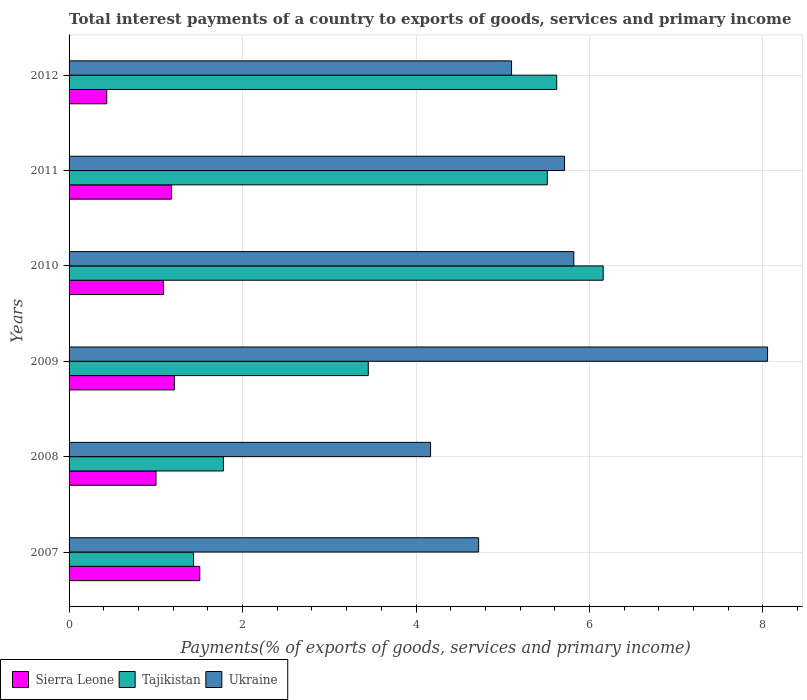How many different coloured bars are there?
Offer a very short reply. 3. How many bars are there on the 2nd tick from the bottom?
Your answer should be compact. 3. What is the label of the 6th group of bars from the top?
Keep it short and to the point. 2007. In how many cases, is the number of bars for a given year not equal to the number of legend labels?
Ensure brevity in your answer.  0. What is the total interest payments in Ukraine in 2011?
Your response must be concise. 5.71. Across all years, what is the maximum total interest payments in Tajikistan?
Give a very brief answer. 6.16. Across all years, what is the minimum total interest payments in Ukraine?
Offer a terse response. 4.17. In which year was the total interest payments in Ukraine maximum?
Ensure brevity in your answer.  2009. In which year was the total interest payments in Sierra Leone minimum?
Provide a short and direct response. 2012. What is the total total interest payments in Ukraine in the graph?
Keep it short and to the point. 33.58. What is the difference between the total interest payments in Sierra Leone in 2010 and that in 2012?
Provide a short and direct response. 0.65. What is the difference between the total interest payments in Tajikistan in 2009 and the total interest payments in Ukraine in 2011?
Your answer should be very brief. -2.26. What is the average total interest payments in Tajikistan per year?
Your answer should be compact. 3.99. In the year 2008, what is the difference between the total interest payments in Ukraine and total interest payments in Tajikistan?
Offer a terse response. 2.39. In how many years, is the total interest payments in Tajikistan greater than 6.8 %?
Your response must be concise. 0. What is the ratio of the total interest payments in Ukraine in 2010 to that in 2011?
Offer a very short reply. 1.02. Is the total interest payments in Sierra Leone in 2009 less than that in 2010?
Provide a short and direct response. No. Is the difference between the total interest payments in Ukraine in 2009 and 2010 greater than the difference between the total interest payments in Tajikistan in 2009 and 2010?
Your answer should be very brief. Yes. What is the difference between the highest and the second highest total interest payments in Sierra Leone?
Your answer should be compact. 0.29. What is the difference between the highest and the lowest total interest payments in Ukraine?
Your answer should be compact. 3.89. Is the sum of the total interest payments in Tajikistan in 2008 and 2012 greater than the maximum total interest payments in Ukraine across all years?
Your answer should be very brief. No. What does the 1st bar from the top in 2012 represents?
Provide a short and direct response. Ukraine. What does the 1st bar from the bottom in 2010 represents?
Offer a terse response. Sierra Leone. Are all the bars in the graph horizontal?
Your answer should be very brief. Yes. How many years are there in the graph?
Your answer should be very brief. 6. What is the difference between two consecutive major ticks on the X-axis?
Provide a short and direct response. 2. Does the graph contain any zero values?
Your answer should be compact. No. Does the graph contain grids?
Keep it short and to the point. Yes. Where does the legend appear in the graph?
Your answer should be compact. Bottom left. How many legend labels are there?
Give a very brief answer. 3. What is the title of the graph?
Provide a succinct answer. Total interest payments of a country to exports of goods, services and primary income. Does "Ireland" appear as one of the legend labels in the graph?
Your response must be concise. No. What is the label or title of the X-axis?
Give a very brief answer. Payments(% of exports of goods, services and primary income). What is the label or title of the Y-axis?
Provide a succinct answer. Years. What is the Payments(% of exports of goods, services and primary income) in Sierra Leone in 2007?
Give a very brief answer. 1.51. What is the Payments(% of exports of goods, services and primary income) of Tajikistan in 2007?
Make the answer very short. 1.43. What is the Payments(% of exports of goods, services and primary income) in Ukraine in 2007?
Give a very brief answer. 4.72. What is the Payments(% of exports of goods, services and primary income) in Sierra Leone in 2008?
Ensure brevity in your answer.  1. What is the Payments(% of exports of goods, services and primary income) in Tajikistan in 2008?
Keep it short and to the point. 1.78. What is the Payments(% of exports of goods, services and primary income) in Ukraine in 2008?
Provide a short and direct response. 4.17. What is the Payments(% of exports of goods, services and primary income) in Sierra Leone in 2009?
Provide a short and direct response. 1.21. What is the Payments(% of exports of goods, services and primary income) in Tajikistan in 2009?
Provide a short and direct response. 3.45. What is the Payments(% of exports of goods, services and primary income) in Ukraine in 2009?
Provide a succinct answer. 8.05. What is the Payments(% of exports of goods, services and primary income) in Sierra Leone in 2010?
Ensure brevity in your answer.  1.09. What is the Payments(% of exports of goods, services and primary income) in Tajikistan in 2010?
Your response must be concise. 6.16. What is the Payments(% of exports of goods, services and primary income) of Ukraine in 2010?
Offer a very short reply. 5.82. What is the Payments(% of exports of goods, services and primary income) in Sierra Leone in 2011?
Offer a very short reply. 1.18. What is the Payments(% of exports of goods, services and primary income) of Tajikistan in 2011?
Provide a short and direct response. 5.51. What is the Payments(% of exports of goods, services and primary income) in Ukraine in 2011?
Provide a succinct answer. 5.71. What is the Payments(% of exports of goods, services and primary income) of Sierra Leone in 2012?
Keep it short and to the point. 0.43. What is the Payments(% of exports of goods, services and primary income) of Tajikistan in 2012?
Provide a succinct answer. 5.62. What is the Payments(% of exports of goods, services and primary income) in Ukraine in 2012?
Make the answer very short. 5.1. Across all years, what is the maximum Payments(% of exports of goods, services and primary income) in Sierra Leone?
Keep it short and to the point. 1.51. Across all years, what is the maximum Payments(% of exports of goods, services and primary income) in Tajikistan?
Offer a terse response. 6.16. Across all years, what is the maximum Payments(% of exports of goods, services and primary income) of Ukraine?
Your answer should be compact. 8.05. Across all years, what is the minimum Payments(% of exports of goods, services and primary income) in Sierra Leone?
Your response must be concise. 0.43. Across all years, what is the minimum Payments(% of exports of goods, services and primary income) in Tajikistan?
Your answer should be very brief. 1.43. Across all years, what is the minimum Payments(% of exports of goods, services and primary income) of Ukraine?
Provide a short and direct response. 4.17. What is the total Payments(% of exports of goods, services and primary income) in Sierra Leone in the graph?
Make the answer very short. 6.43. What is the total Payments(% of exports of goods, services and primary income) in Tajikistan in the graph?
Provide a succinct answer. 23.96. What is the total Payments(% of exports of goods, services and primary income) of Ukraine in the graph?
Your answer should be compact. 33.58. What is the difference between the Payments(% of exports of goods, services and primary income) of Sierra Leone in 2007 and that in 2008?
Make the answer very short. 0.5. What is the difference between the Payments(% of exports of goods, services and primary income) of Tajikistan in 2007 and that in 2008?
Provide a succinct answer. -0.34. What is the difference between the Payments(% of exports of goods, services and primary income) in Ukraine in 2007 and that in 2008?
Make the answer very short. 0.55. What is the difference between the Payments(% of exports of goods, services and primary income) of Sierra Leone in 2007 and that in 2009?
Offer a very short reply. 0.29. What is the difference between the Payments(% of exports of goods, services and primary income) of Tajikistan in 2007 and that in 2009?
Provide a succinct answer. -2.01. What is the difference between the Payments(% of exports of goods, services and primary income) of Ukraine in 2007 and that in 2009?
Give a very brief answer. -3.33. What is the difference between the Payments(% of exports of goods, services and primary income) in Sierra Leone in 2007 and that in 2010?
Offer a terse response. 0.42. What is the difference between the Payments(% of exports of goods, services and primary income) in Tajikistan in 2007 and that in 2010?
Give a very brief answer. -4.72. What is the difference between the Payments(% of exports of goods, services and primary income) in Ukraine in 2007 and that in 2010?
Give a very brief answer. -1.1. What is the difference between the Payments(% of exports of goods, services and primary income) in Sierra Leone in 2007 and that in 2011?
Your answer should be very brief. 0.33. What is the difference between the Payments(% of exports of goods, services and primary income) in Tajikistan in 2007 and that in 2011?
Provide a succinct answer. -4.08. What is the difference between the Payments(% of exports of goods, services and primary income) in Ukraine in 2007 and that in 2011?
Provide a succinct answer. -0.99. What is the difference between the Payments(% of exports of goods, services and primary income) of Sierra Leone in 2007 and that in 2012?
Keep it short and to the point. 1.07. What is the difference between the Payments(% of exports of goods, services and primary income) in Tajikistan in 2007 and that in 2012?
Offer a terse response. -4.19. What is the difference between the Payments(% of exports of goods, services and primary income) of Ukraine in 2007 and that in 2012?
Your answer should be very brief. -0.38. What is the difference between the Payments(% of exports of goods, services and primary income) in Sierra Leone in 2008 and that in 2009?
Your response must be concise. -0.21. What is the difference between the Payments(% of exports of goods, services and primary income) in Tajikistan in 2008 and that in 2009?
Ensure brevity in your answer.  -1.67. What is the difference between the Payments(% of exports of goods, services and primary income) of Ukraine in 2008 and that in 2009?
Provide a succinct answer. -3.89. What is the difference between the Payments(% of exports of goods, services and primary income) in Sierra Leone in 2008 and that in 2010?
Your response must be concise. -0.09. What is the difference between the Payments(% of exports of goods, services and primary income) of Tajikistan in 2008 and that in 2010?
Ensure brevity in your answer.  -4.38. What is the difference between the Payments(% of exports of goods, services and primary income) in Ukraine in 2008 and that in 2010?
Ensure brevity in your answer.  -1.65. What is the difference between the Payments(% of exports of goods, services and primary income) in Sierra Leone in 2008 and that in 2011?
Offer a very short reply. -0.18. What is the difference between the Payments(% of exports of goods, services and primary income) in Tajikistan in 2008 and that in 2011?
Offer a terse response. -3.73. What is the difference between the Payments(% of exports of goods, services and primary income) of Ukraine in 2008 and that in 2011?
Keep it short and to the point. -1.54. What is the difference between the Payments(% of exports of goods, services and primary income) in Sierra Leone in 2008 and that in 2012?
Offer a very short reply. 0.57. What is the difference between the Payments(% of exports of goods, services and primary income) of Tajikistan in 2008 and that in 2012?
Ensure brevity in your answer.  -3.84. What is the difference between the Payments(% of exports of goods, services and primary income) of Ukraine in 2008 and that in 2012?
Make the answer very short. -0.93. What is the difference between the Payments(% of exports of goods, services and primary income) of Sierra Leone in 2009 and that in 2010?
Provide a succinct answer. 0.13. What is the difference between the Payments(% of exports of goods, services and primary income) in Tajikistan in 2009 and that in 2010?
Provide a short and direct response. -2.71. What is the difference between the Payments(% of exports of goods, services and primary income) of Ukraine in 2009 and that in 2010?
Ensure brevity in your answer.  2.23. What is the difference between the Payments(% of exports of goods, services and primary income) in Sierra Leone in 2009 and that in 2011?
Keep it short and to the point. 0.03. What is the difference between the Payments(% of exports of goods, services and primary income) of Tajikistan in 2009 and that in 2011?
Offer a very short reply. -2.06. What is the difference between the Payments(% of exports of goods, services and primary income) of Ukraine in 2009 and that in 2011?
Offer a very short reply. 2.34. What is the difference between the Payments(% of exports of goods, services and primary income) of Sierra Leone in 2009 and that in 2012?
Your answer should be compact. 0.78. What is the difference between the Payments(% of exports of goods, services and primary income) of Tajikistan in 2009 and that in 2012?
Ensure brevity in your answer.  -2.17. What is the difference between the Payments(% of exports of goods, services and primary income) of Ukraine in 2009 and that in 2012?
Make the answer very short. 2.95. What is the difference between the Payments(% of exports of goods, services and primary income) in Sierra Leone in 2010 and that in 2011?
Your answer should be very brief. -0.09. What is the difference between the Payments(% of exports of goods, services and primary income) in Tajikistan in 2010 and that in 2011?
Keep it short and to the point. 0.64. What is the difference between the Payments(% of exports of goods, services and primary income) in Ukraine in 2010 and that in 2011?
Make the answer very short. 0.11. What is the difference between the Payments(% of exports of goods, services and primary income) of Sierra Leone in 2010 and that in 2012?
Offer a very short reply. 0.65. What is the difference between the Payments(% of exports of goods, services and primary income) in Tajikistan in 2010 and that in 2012?
Ensure brevity in your answer.  0.54. What is the difference between the Payments(% of exports of goods, services and primary income) in Ukraine in 2010 and that in 2012?
Your response must be concise. 0.72. What is the difference between the Payments(% of exports of goods, services and primary income) of Sierra Leone in 2011 and that in 2012?
Your answer should be compact. 0.75. What is the difference between the Payments(% of exports of goods, services and primary income) in Tajikistan in 2011 and that in 2012?
Offer a very short reply. -0.11. What is the difference between the Payments(% of exports of goods, services and primary income) in Ukraine in 2011 and that in 2012?
Ensure brevity in your answer.  0.61. What is the difference between the Payments(% of exports of goods, services and primary income) of Sierra Leone in 2007 and the Payments(% of exports of goods, services and primary income) of Tajikistan in 2008?
Give a very brief answer. -0.27. What is the difference between the Payments(% of exports of goods, services and primary income) in Sierra Leone in 2007 and the Payments(% of exports of goods, services and primary income) in Ukraine in 2008?
Your answer should be very brief. -2.66. What is the difference between the Payments(% of exports of goods, services and primary income) in Tajikistan in 2007 and the Payments(% of exports of goods, services and primary income) in Ukraine in 2008?
Your response must be concise. -2.73. What is the difference between the Payments(% of exports of goods, services and primary income) in Sierra Leone in 2007 and the Payments(% of exports of goods, services and primary income) in Tajikistan in 2009?
Ensure brevity in your answer.  -1.94. What is the difference between the Payments(% of exports of goods, services and primary income) of Sierra Leone in 2007 and the Payments(% of exports of goods, services and primary income) of Ukraine in 2009?
Ensure brevity in your answer.  -6.55. What is the difference between the Payments(% of exports of goods, services and primary income) in Tajikistan in 2007 and the Payments(% of exports of goods, services and primary income) in Ukraine in 2009?
Provide a succinct answer. -6.62. What is the difference between the Payments(% of exports of goods, services and primary income) in Sierra Leone in 2007 and the Payments(% of exports of goods, services and primary income) in Tajikistan in 2010?
Provide a short and direct response. -4.65. What is the difference between the Payments(% of exports of goods, services and primary income) of Sierra Leone in 2007 and the Payments(% of exports of goods, services and primary income) of Ukraine in 2010?
Provide a succinct answer. -4.31. What is the difference between the Payments(% of exports of goods, services and primary income) of Tajikistan in 2007 and the Payments(% of exports of goods, services and primary income) of Ukraine in 2010?
Make the answer very short. -4.38. What is the difference between the Payments(% of exports of goods, services and primary income) of Sierra Leone in 2007 and the Payments(% of exports of goods, services and primary income) of Tajikistan in 2011?
Keep it short and to the point. -4.01. What is the difference between the Payments(% of exports of goods, services and primary income) in Sierra Leone in 2007 and the Payments(% of exports of goods, services and primary income) in Ukraine in 2011?
Offer a terse response. -4.21. What is the difference between the Payments(% of exports of goods, services and primary income) of Tajikistan in 2007 and the Payments(% of exports of goods, services and primary income) of Ukraine in 2011?
Your answer should be compact. -4.28. What is the difference between the Payments(% of exports of goods, services and primary income) in Sierra Leone in 2007 and the Payments(% of exports of goods, services and primary income) in Tajikistan in 2012?
Make the answer very short. -4.12. What is the difference between the Payments(% of exports of goods, services and primary income) of Sierra Leone in 2007 and the Payments(% of exports of goods, services and primary income) of Ukraine in 2012?
Offer a terse response. -3.59. What is the difference between the Payments(% of exports of goods, services and primary income) of Tajikistan in 2007 and the Payments(% of exports of goods, services and primary income) of Ukraine in 2012?
Offer a very short reply. -3.67. What is the difference between the Payments(% of exports of goods, services and primary income) of Sierra Leone in 2008 and the Payments(% of exports of goods, services and primary income) of Tajikistan in 2009?
Offer a terse response. -2.45. What is the difference between the Payments(% of exports of goods, services and primary income) of Sierra Leone in 2008 and the Payments(% of exports of goods, services and primary income) of Ukraine in 2009?
Give a very brief answer. -7.05. What is the difference between the Payments(% of exports of goods, services and primary income) of Tajikistan in 2008 and the Payments(% of exports of goods, services and primary income) of Ukraine in 2009?
Ensure brevity in your answer.  -6.27. What is the difference between the Payments(% of exports of goods, services and primary income) of Sierra Leone in 2008 and the Payments(% of exports of goods, services and primary income) of Tajikistan in 2010?
Keep it short and to the point. -5.16. What is the difference between the Payments(% of exports of goods, services and primary income) in Sierra Leone in 2008 and the Payments(% of exports of goods, services and primary income) in Ukraine in 2010?
Provide a short and direct response. -4.82. What is the difference between the Payments(% of exports of goods, services and primary income) in Tajikistan in 2008 and the Payments(% of exports of goods, services and primary income) in Ukraine in 2010?
Offer a terse response. -4.04. What is the difference between the Payments(% of exports of goods, services and primary income) of Sierra Leone in 2008 and the Payments(% of exports of goods, services and primary income) of Tajikistan in 2011?
Make the answer very short. -4.51. What is the difference between the Payments(% of exports of goods, services and primary income) in Sierra Leone in 2008 and the Payments(% of exports of goods, services and primary income) in Ukraine in 2011?
Keep it short and to the point. -4.71. What is the difference between the Payments(% of exports of goods, services and primary income) in Tajikistan in 2008 and the Payments(% of exports of goods, services and primary income) in Ukraine in 2011?
Keep it short and to the point. -3.93. What is the difference between the Payments(% of exports of goods, services and primary income) of Sierra Leone in 2008 and the Payments(% of exports of goods, services and primary income) of Tajikistan in 2012?
Keep it short and to the point. -4.62. What is the difference between the Payments(% of exports of goods, services and primary income) of Sierra Leone in 2008 and the Payments(% of exports of goods, services and primary income) of Ukraine in 2012?
Your answer should be very brief. -4.1. What is the difference between the Payments(% of exports of goods, services and primary income) of Tajikistan in 2008 and the Payments(% of exports of goods, services and primary income) of Ukraine in 2012?
Your answer should be very brief. -3.32. What is the difference between the Payments(% of exports of goods, services and primary income) of Sierra Leone in 2009 and the Payments(% of exports of goods, services and primary income) of Tajikistan in 2010?
Give a very brief answer. -4.94. What is the difference between the Payments(% of exports of goods, services and primary income) in Sierra Leone in 2009 and the Payments(% of exports of goods, services and primary income) in Ukraine in 2010?
Offer a terse response. -4.61. What is the difference between the Payments(% of exports of goods, services and primary income) in Tajikistan in 2009 and the Payments(% of exports of goods, services and primary income) in Ukraine in 2010?
Make the answer very short. -2.37. What is the difference between the Payments(% of exports of goods, services and primary income) of Sierra Leone in 2009 and the Payments(% of exports of goods, services and primary income) of Tajikistan in 2011?
Provide a short and direct response. -4.3. What is the difference between the Payments(% of exports of goods, services and primary income) in Sierra Leone in 2009 and the Payments(% of exports of goods, services and primary income) in Ukraine in 2011?
Your answer should be very brief. -4.5. What is the difference between the Payments(% of exports of goods, services and primary income) of Tajikistan in 2009 and the Payments(% of exports of goods, services and primary income) of Ukraine in 2011?
Ensure brevity in your answer.  -2.26. What is the difference between the Payments(% of exports of goods, services and primary income) of Sierra Leone in 2009 and the Payments(% of exports of goods, services and primary income) of Tajikistan in 2012?
Make the answer very short. -4.41. What is the difference between the Payments(% of exports of goods, services and primary income) in Sierra Leone in 2009 and the Payments(% of exports of goods, services and primary income) in Ukraine in 2012?
Offer a terse response. -3.89. What is the difference between the Payments(% of exports of goods, services and primary income) of Tajikistan in 2009 and the Payments(% of exports of goods, services and primary income) of Ukraine in 2012?
Give a very brief answer. -1.65. What is the difference between the Payments(% of exports of goods, services and primary income) in Sierra Leone in 2010 and the Payments(% of exports of goods, services and primary income) in Tajikistan in 2011?
Ensure brevity in your answer.  -4.43. What is the difference between the Payments(% of exports of goods, services and primary income) in Sierra Leone in 2010 and the Payments(% of exports of goods, services and primary income) in Ukraine in 2011?
Provide a short and direct response. -4.62. What is the difference between the Payments(% of exports of goods, services and primary income) of Tajikistan in 2010 and the Payments(% of exports of goods, services and primary income) of Ukraine in 2011?
Keep it short and to the point. 0.45. What is the difference between the Payments(% of exports of goods, services and primary income) of Sierra Leone in 2010 and the Payments(% of exports of goods, services and primary income) of Tajikistan in 2012?
Offer a very short reply. -4.53. What is the difference between the Payments(% of exports of goods, services and primary income) of Sierra Leone in 2010 and the Payments(% of exports of goods, services and primary income) of Ukraine in 2012?
Make the answer very short. -4.01. What is the difference between the Payments(% of exports of goods, services and primary income) of Tajikistan in 2010 and the Payments(% of exports of goods, services and primary income) of Ukraine in 2012?
Provide a succinct answer. 1.06. What is the difference between the Payments(% of exports of goods, services and primary income) in Sierra Leone in 2011 and the Payments(% of exports of goods, services and primary income) in Tajikistan in 2012?
Ensure brevity in your answer.  -4.44. What is the difference between the Payments(% of exports of goods, services and primary income) in Sierra Leone in 2011 and the Payments(% of exports of goods, services and primary income) in Ukraine in 2012?
Make the answer very short. -3.92. What is the difference between the Payments(% of exports of goods, services and primary income) of Tajikistan in 2011 and the Payments(% of exports of goods, services and primary income) of Ukraine in 2012?
Provide a short and direct response. 0.41. What is the average Payments(% of exports of goods, services and primary income) of Sierra Leone per year?
Keep it short and to the point. 1.07. What is the average Payments(% of exports of goods, services and primary income) of Tajikistan per year?
Your answer should be very brief. 3.99. What is the average Payments(% of exports of goods, services and primary income) in Ukraine per year?
Ensure brevity in your answer.  5.6. In the year 2007, what is the difference between the Payments(% of exports of goods, services and primary income) of Sierra Leone and Payments(% of exports of goods, services and primary income) of Tajikistan?
Give a very brief answer. 0.07. In the year 2007, what is the difference between the Payments(% of exports of goods, services and primary income) of Sierra Leone and Payments(% of exports of goods, services and primary income) of Ukraine?
Give a very brief answer. -3.22. In the year 2007, what is the difference between the Payments(% of exports of goods, services and primary income) in Tajikistan and Payments(% of exports of goods, services and primary income) in Ukraine?
Give a very brief answer. -3.29. In the year 2008, what is the difference between the Payments(% of exports of goods, services and primary income) of Sierra Leone and Payments(% of exports of goods, services and primary income) of Tajikistan?
Your answer should be very brief. -0.78. In the year 2008, what is the difference between the Payments(% of exports of goods, services and primary income) of Sierra Leone and Payments(% of exports of goods, services and primary income) of Ukraine?
Provide a succinct answer. -3.17. In the year 2008, what is the difference between the Payments(% of exports of goods, services and primary income) in Tajikistan and Payments(% of exports of goods, services and primary income) in Ukraine?
Your answer should be very brief. -2.39. In the year 2009, what is the difference between the Payments(% of exports of goods, services and primary income) in Sierra Leone and Payments(% of exports of goods, services and primary income) in Tajikistan?
Make the answer very short. -2.24. In the year 2009, what is the difference between the Payments(% of exports of goods, services and primary income) in Sierra Leone and Payments(% of exports of goods, services and primary income) in Ukraine?
Keep it short and to the point. -6.84. In the year 2009, what is the difference between the Payments(% of exports of goods, services and primary income) of Tajikistan and Payments(% of exports of goods, services and primary income) of Ukraine?
Provide a succinct answer. -4.6. In the year 2010, what is the difference between the Payments(% of exports of goods, services and primary income) in Sierra Leone and Payments(% of exports of goods, services and primary income) in Tajikistan?
Keep it short and to the point. -5.07. In the year 2010, what is the difference between the Payments(% of exports of goods, services and primary income) in Sierra Leone and Payments(% of exports of goods, services and primary income) in Ukraine?
Ensure brevity in your answer.  -4.73. In the year 2010, what is the difference between the Payments(% of exports of goods, services and primary income) in Tajikistan and Payments(% of exports of goods, services and primary income) in Ukraine?
Your answer should be very brief. 0.34. In the year 2011, what is the difference between the Payments(% of exports of goods, services and primary income) in Sierra Leone and Payments(% of exports of goods, services and primary income) in Tajikistan?
Your answer should be compact. -4.33. In the year 2011, what is the difference between the Payments(% of exports of goods, services and primary income) of Sierra Leone and Payments(% of exports of goods, services and primary income) of Ukraine?
Give a very brief answer. -4.53. In the year 2011, what is the difference between the Payments(% of exports of goods, services and primary income) in Tajikistan and Payments(% of exports of goods, services and primary income) in Ukraine?
Provide a short and direct response. -0.2. In the year 2012, what is the difference between the Payments(% of exports of goods, services and primary income) in Sierra Leone and Payments(% of exports of goods, services and primary income) in Tajikistan?
Keep it short and to the point. -5.19. In the year 2012, what is the difference between the Payments(% of exports of goods, services and primary income) in Sierra Leone and Payments(% of exports of goods, services and primary income) in Ukraine?
Your response must be concise. -4.67. In the year 2012, what is the difference between the Payments(% of exports of goods, services and primary income) in Tajikistan and Payments(% of exports of goods, services and primary income) in Ukraine?
Your answer should be very brief. 0.52. What is the ratio of the Payments(% of exports of goods, services and primary income) of Sierra Leone in 2007 to that in 2008?
Provide a short and direct response. 1.5. What is the ratio of the Payments(% of exports of goods, services and primary income) in Tajikistan in 2007 to that in 2008?
Your response must be concise. 0.81. What is the ratio of the Payments(% of exports of goods, services and primary income) of Ukraine in 2007 to that in 2008?
Your answer should be compact. 1.13. What is the ratio of the Payments(% of exports of goods, services and primary income) of Sierra Leone in 2007 to that in 2009?
Your response must be concise. 1.24. What is the ratio of the Payments(% of exports of goods, services and primary income) of Tajikistan in 2007 to that in 2009?
Your answer should be compact. 0.42. What is the ratio of the Payments(% of exports of goods, services and primary income) of Ukraine in 2007 to that in 2009?
Keep it short and to the point. 0.59. What is the ratio of the Payments(% of exports of goods, services and primary income) of Sierra Leone in 2007 to that in 2010?
Your answer should be compact. 1.38. What is the ratio of the Payments(% of exports of goods, services and primary income) in Tajikistan in 2007 to that in 2010?
Provide a short and direct response. 0.23. What is the ratio of the Payments(% of exports of goods, services and primary income) of Ukraine in 2007 to that in 2010?
Your response must be concise. 0.81. What is the ratio of the Payments(% of exports of goods, services and primary income) of Sierra Leone in 2007 to that in 2011?
Keep it short and to the point. 1.28. What is the ratio of the Payments(% of exports of goods, services and primary income) in Tajikistan in 2007 to that in 2011?
Ensure brevity in your answer.  0.26. What is the ratio of the Payments(% of exports of goods, services and primary income) in Ukraine in 2007 to that in 2011?
Give a very brief answer. 0.83. What is the ratio of the Payments(% of exports of goods, services and primary income) in Sierra Leone in 2007 to that in 2012?
Give a very brief answer. 3.47. What is the ratio of the Payments(% of exports of goods, services and primary income) in Tajikistan in 2007 to that in 2012?
Your answer should be very brief. 0.26. What is the ratio of the Payments(% of exports of goods, services and primary income) of Ukraine in 2007 to that in 2012?
Provide a succinct answer. 0.93. What is the ratio of the Payments(% of exports of goods, services and primary income) of Sierra Leone in 2008 to that in 2009?
Your answer should be very brief. 0.83. What is the ratio of the Payments(% of exports of goods, services and primary income) of Tajikistan in 2008 to that in 2009?
Your response must be concise. 0.52. What is the ratio of the Payments(% of exports of goods, services and primary income) of Ukraine in 2008 to that in 2009?
Your answer should be very brief. 0.52. What is the ratio of the Payments(% of exports of goods, services and primary income) in Sierra Leone in 2008 to that in 2010?
Provide a short and direct response. 0.92. What is the ratio of the Payments(% of exports of goods, services and primary income) in Tajikistan in 2008 to that in 2010?
Your answer should be compact. 0.29. What is the ratio of the Payments(% of exports of goods, services and primary income) of Ukraine in 2008 to that in 2010?
Ensure brevity in your answer.  0.72. What is the ratio of the Payments(% of exports of goods, services and primary income) of Sierra Leone in 2008 to that in 2011?
Your answer should be very brief. 0.85. What is the ratio of the Payments(% of exports of goods, services and primary income) in Tajikistan in 2008 to that in 2011?
Offer a terse response. 0.32. What is the ratio of the Payments(% of exports of goods, services and primary income) in Ukraine in 2008 to that in 2011?
Give a very brief answer. 0.73. What is the ratio of the Payments(% of exports of goods, services and primary income) of Sierra Leone in 2008 to that in 2012?
Provide a succinct answer. 2.31. What is the ratio of the Payments(% of exports of goods, services and primary income) in Tajikistan in 2008 to that in 2012?
Give a very brief answer. 0.32. What is the ratio of the Payments(% of exports of goods, services and primary income) in Ukraine in 2008 to that in 2012?
Keep it short and to the point. 0.82. What is the ratio of the Payments(% of exports of goods, services and primary income) in Sierra Leone in 2009 to that in 2010?
Give a very brief answer. 1.12. What is the ratio of the Payments(% of exports of goods, services and primary income) in Tajikistan in 2009 to that in 2010?
Provide a short and direct response. 0.56. What is the ratio of the Payments(% of exports of goods, services and primary income) in Ukraine in 2009 to that in 2010?
Provide a succinct answer. 1.38. What is the ratio of the Payments(% of exports of goods, services and primary income) of Sierra Leone in 2009 to that in 2011?
Offer a very short reply. 1.03. What is the ratio of the Payments(% of exports of goods, services and primary income) in Tajikistan in 2009 to that in 2011?
Offer a very short reply. 0.63. What is the ratio of the Payments(% of exports of goods, services and primary income) of Ukraine in 2009 to that in 2011?
Your answer should be very brief. 1.41. What is the ratio of the Payments(% of exports of goods, services and primary income) in Sierra Leone in 2009 to that in 2012?
Provide a short and direct response. 2.8. What is the ratio of the Payments(% of exports of goods, services and primary income) of Tajikistan in 2009 to that in 2012?
Make the answer very short. 0.61. What is the ratio of the Payments(% of exports of goods, services and primary income) in Ukraine in 2009 to that in 2012?
Your answer should be compact. 1.58. What is the ratio of the Payments(% of exports of goods, services and primary income) of Sierra Leone in 2010 to that in 2011?
Offer a very short reply. 0.92. What is the ratio of the Payments(% of exports of goods, services and primary income) of Tajikistan in 2010 to that in 2011?
Give a very brief answer. 1.12. What is the ratio of the Payments(% of exports of goods, services and primary income) in Ukraine in 2010 to that in 2011?
Provide a succinct answer. 1.02. What is the ratio of the Payments(% of exports of goods, services and primary income) of Sierra Leone in 2010 to that in 2012?
Keep it short and to the point. 2.5. What is the ratio of the Payments(% of exports of goods, services and primary income) in Tajikistan in 2010 to that in 2012?
Your answer should be very brief. 1.1. What is the ratio of the Payments(% of exports of goods, services and primary income) of Ukraine in 2010 to that in 2012?
Give a very brief answer. 1.14. What is the ratio of the Payments(% of exports of goods, services and primary income) of Sierra Leone in 2011 to that in 2012?
Keep it short and to the point. 2.72. What is the ratio of the Payments(% of exports of goods, services and primary income) of Tajikistan in 2011 to that in 2012?
Provide a short and direct response. 0.98. What is the ratio of the Payments(% of exports of goods, services and primary income) of Ukraine in 2011 to that in 2012?
Provide a succinct answer. 1.12. What is the difference between the highest and the second highest Payments(% of exports of goods, services and primary income) of Sierra Leone?
Give a very brief answer. 0.29. What is the difference between the highest and the second highest Payments(% of exports of goods, services and primary income) in Tajikistan?
Provide a short and direct response. 0.54. What is the difference between the highest and the second highest Payments(% of exports of goods, services and primary income) in Ukraine?
Ensure brevity in your answer.  2.23. What is the difference between the highest and the lowest Payments(% of exports of goods, services and primary income) of Sierra Leone?
Provide a short and direct response. 1.07. What is the difference between the highest and the lowest Payments(% of exports of goods, services and primary income) in Tajikistan?
Your answer should be very brief. 4.72. What is the difference between the highest and the lowest Payments(% of exports of goods, services and primary income) of Ukraine?
Provide a succinct answer. 3.89. 